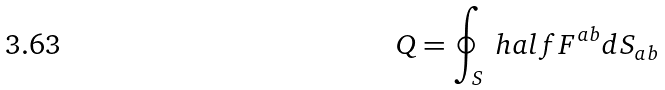Convert formula to latex. <formula><loc_0><loc_0><loc_500><loc_500>Q = \oint _ { S } \ h a l f F ^ { a b } d S _ { a b }</formula> 